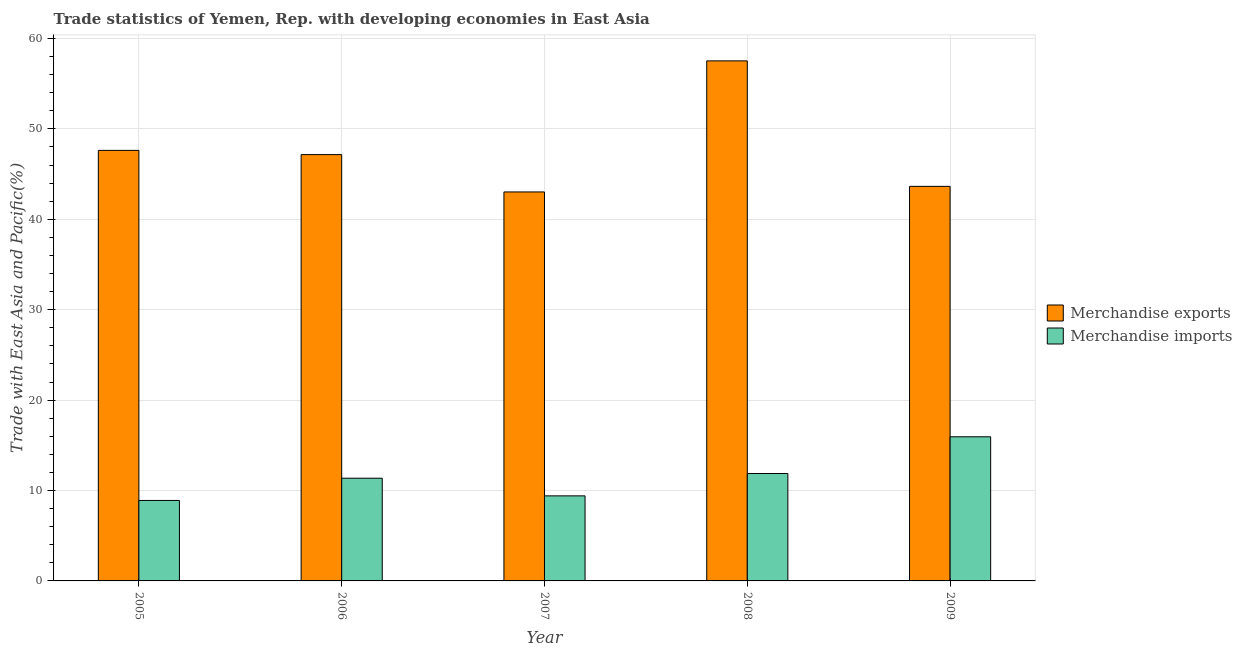How many different coloured bars are there?
Your response must be concise. 2. How many groups of bars are there?
Your answer should be very brief. 5. Are the number of bars on each tick of the X-axis equal?
Offer a terse response. Yes. How many bars are there on the 2nd tick from the left?
Provide a short and direct response. 2. What is the merchandise exports in 2007?
Give a very brief answer. 43.03. Across all years, what is the maximum merchandise exports?
Your response must be concise. 57.53. Across all years, what is the minimum merchandise imports?
Your answer should be very brief. 8.9. What is the total merchandise exports in the graph?
Your response must be concise. 238.98. What is the difference between the merchandise exports in 2006 and that in 2007?
Your answer should be compact. 4.13. What is the difference between the merchandise exports in 2005 and the merchandise imports in 2007?
Provide a succinct answer. 4.6. What is the average merchandise imports per year?
Offer a terse response. 11.5. In the year 2009, what is the difference between the merchandise imports and merchandise exports?
Provide a succinct answer. 0. What is the ratio of the merchandise imports in 2005 to that in 2007?
Provide a succinct answer. 0.95. Is the merchandise imports in 2005 less than that in 2006?
Provide a short and direct response. Yes. What is the difference between the highest and the second highest merchandise imports?
Ensure brevity in your answer.  4.06. What is the difference between the highest and the lowest merchandise exports?
Your answer should be very brief. 14.5. Is the sum of the merchandise imports in 2006 and 2007 greater than the maximum merchandise exports across all years?
Provide a succinct answer. Yes. What does the 1st bar from the left in 2007 represents?
Ensure brevity in your answer.  Merchandise exports. Are all the bars in the graph horizontal?
Your answer should be very brief. No. Are the values on the major ticks of Y-axis written in scientific E-notation?
Ensure brevity in your answer.  No. Does the graph contain any zero values?
Your answer should be very brief. No. How many legend labels are there?
Offer a very short reply. 2. What is the title of the graph?
Offer a terse response. Trade statistics of Yemen, Rep. with developing economies in East Asia. Does "Not attending school" appear as one of the legend labels in the graph?
Offer a very short reply. No. What is the label or title of the X-axis?
Provide a short and direct response. Year. What is the label or title of the Y-axis?
Offer a very short reply. Trade with East Asia and Pacific(%). What is the Trade with East Asia and Pacific(%) in Merchandise exports in 2005?
Make the answer very short. 47.63. What is the Trade with East Asia and Pacific(%) of Merchandise imports in 2005?
Provide a succinct answer. 8.9. What is the Trade with East Asia and Pacific(%) in Merchandise exports in 2006?
Offer a very short reply. 47.16. What is the Trade with East Asia and Pacific(%) in Merchandise imports in 2006?
Give a very brief answer. 11.36. What is the Trade with East Asia and Pacific(%) in Merchandise exports in 2007?
Give a very brief answer. 43.03. What is the Trade with East Asia and Pacific(%) in Merchandise imports in 2007?
Keep it short and to the point. 9.41. What is the Trade with East Asia and Pacific(%) in Merchandise exports in 2008?
Provide a short and direct response. 57.53. What is the Trade with East Asia and Pacific(%) of Merchandise imports in 2008?
Make the answer very short. 11.88. What is the Trade with East Asia and Pacific(%) of Merchandise exports in 2009?
Make the answer very short. 43.65. What is the Trade with East Asia and Pacific(%) of Merchandise imports in 2009?
Your answer should be very brief. 15.94. Across all years, what is the maximum Trade with East Asia and Pacific(%) in Merchandise exports?
Offer a terse response. 57.53. Across all years, what is the maximum Trade with East Asia and Pacific(%) of Merchandise imports?
Your answer should be very brief. 15.94. Across all years, what is the minimum Trade with East Asia and Pacific(%) in Merchandise exports?
Ensure brevity in your answer.  43.03. Across all years, what is the minimum Trade with East Asia and Pacific(%) of Merchandise imports?
Your answer should be very brief. 8.9. What is the total Trade with East Asia and Pacific(%) of Merchandise exports in the graph?
Your response must be concise. 238.98. What is the total Trade with East Asia and Pacific(%) in Merchandise imports in the graph?
Offer a very short reply. 57.5. What is the difference between the Trade with East Asia and Pacific(%) of Merchandise exports in 2005 and that in 2006?
Provide a succinct answer. 0.47. What is the difference between the Trade with East Asia and Pacific(%) of Merchandise imports in 2005 and that in 2006?
Offer a very short reply. -2.46. What is the difference between the Trade with East Asia and Pacific(%) in Merchandise exports in 2005 and that in 2007?
Offer a very short reply. 4.6. What is the difference between the Trade with East Asia and Pacific(%) in Merchandise imports in 2005 and that in 2007?
Give a very brief answer. -0.51. What is the difference between the Trade with East Asia and Pacific(%) of Merchandise exports in 2005 and that in 2008?
Your answer should be compact. -9.9. What is the difference between the Trade with East Asia and Pacific(%) in Merchandise imports in 2005 and that in 2008?
Provide a short and direct response. -2.98. What is the difference between the Trade with East Asia and Pacific(%) in Merchandise exports in 2005 and that in 2009?
Provide a short and direct response. 3.98. What is the difference between the Trade with East Asia and Pacific(%) of Merchandise imports in 2005 and that in 2009?
Offer a terse response. -7.04. What is the difference between the Trade with East Asia and Pacific(%) of Merchandise exports in 2006 and that in 2007?
Provide a short and direct response. 4.13. What is the difference between the Trade with East Asia and Pacific(%) in Merchandise imports in 2006 and that in 2007?
Ensure brevity in your answer.  1.95. What is the difference between the Trade with East Asia and Pacific(%) in Merchandise exports in 2006 and that in 2008?
Your response must be concise. -10.37. What is the difference between the Trade with East Asia and Pacific(%) of Merchandise imports in 2006 and that in 2008?
Give a very brief answer. -0.52. What is the difference between the Trade with East Asia and Pacific(%) of Merchandise exports in 2006 and that in 2009?
Provide a short and direct response. 3.51. What is the difference between the Trade with East Asia and Pacific(%) of Merchandise imports in 2006 and that in 2009?
Your answer should be very brief. -4.58. What is the difference between the Trade with East Asia and Pacific(%) in Merchandise exports in 2007 and that in 2008?
Provide a succinct answer. -14.5. What is the difference between the Trade with East Asia and Pacific(%) in Merchandise imports in 2007 and that in 2008?
Ensure brevity in your answer.  -2.47. What is the difference between the Trade with East Asia and Pacific(%) of Merchandise exports in 2007 and that in 2009?
Your response must be concise. -0.62. What is the difference between the Trade with East Asia and Pacific(%) of Merchandise imports in 2007 and that in 2009?
Give a very brief answer. -6.54. What is the difference between the Trade with East Asia and Pacific(%) of Merchandise exports in 2008 and that in 2009?
Give a very brief answer. 13.88. What is the difference between the Trade with East Asia and Pacific(%) of Merchandise imports in 2008 and that in 2009?
Ensure brevity in your answer.  -4.06. What is the difference between the Trade with East Asia and Pacific(%) of Merchandise exports in 2005 and the Trade with East Asia and Pacific(%) of Merchandise imports in 2006?
Keep it short and to the point. 36.26. What is the difference between the Trade with East Asia and Pacific(%) in Merchandise exports in 2005 and the Trade with East Asia and Pacific(%) in Merchandise imports in 2007?
Offer a terse response. 38.22. What is the difference between the Trade with East Asia and Pacific(%) in Merchandise exports in 2005 and the Trade with East Asia and Pacific(%) in Merchandise imports in 2008?
Your answer should be compact. 35.74. What is the difference between the Trade with East Asia and Pacific(%) in Merchandise exports in 2005 and the Trade with East Asia and Pacific(%) in Merchandise imports in 2009?
Keep it short and to the point. 31.68. What is the difference between the Trade with East Asia and Pacific(%) of Merchandise exports in 2006 and the Trade with East Asia and Pacific(%) of Merchandise imports in 2007?
Make the answer very short. 37.75. What is the difference between the Trade with East Asia and Pacific(%) in Merchandise exports in 2006 and the Trade with East Asia and Pacific(%) in Merchandise imports in 2008?
Keep it short and to the point. 35.28. What is the difference between the Trade with East Asia and Pacific(%) of Merchandise exports in 2006 and the Trade with East Asia and Pacific(%) of Merchandise imports in 2009?
Provide a succinct answer. 31.21. What is the difference between the Trade with East Asia and Pacific(%) in Merchandise exports in 2007 and the Trade with East Asia and Pacific(%) in Merchandise imports in 2008?
Offer a very short reply. 31.15. What is the difference between the Trade with East Asia and Pacific(%) in Merchandise exports in 2007 and the Trade with East Asia and Pacific(%) in Merchandise imports in 2009?
Give a very brief answer. 27.08. What is the difference between the Trade with East Asia and Pacific(%) in Merchandise exports in 2008 and the Trade with East Asia and Pacific(%) in Merchandise imports in 2009?
Provide a succinct answer. 41.58. What is the average Trade with East Asia and Pacific(%) in Merchandise exports per year?
Your response must be concise. 47.8. What is the average Trade with East Asia and Pacific(%) in Merchandise imports per year?
Provide a succinct answer. 11.5. In the year 2005, what is the difference between the Trade with East Asia and Pacific(%) of Merchandise exports and Trade with East Asia and Pacific(%) of Merchandise imports?
Your answer should be very brief. 38.73. In the year 2006, what is the difference between the Trade with East Asia and Pacific(%) of Merchandise exports and Trade with East Asia and Pacific(%) of Merchandise imports?
Provide a succinct answer. 35.8. In the year 2007, what is the difference between the Trade with East Asia and Pacific(%) of Merchandise exports and Trade with East Asia and Pacific(%) of Merchandise imports?
Ensure brevity in your answer.  33.62. In the year 2008, what is the difference between the Trade with East Asia and Pacific(%) in Merchandise exports and Trade with East Asia and Pacific(%) in Merchandise imports?
Ensure brevity in your answer.  45.65. In the year 2009, what is the difference between the Trade with East Asia and Pacific(%) in Merchandise exports and Trade with East Asia and Pacific(%) in Merchandise imports?
Keep it short and to the point. 27.7. What is the ratio of the Trade with East Asia and Pacific(%) in Merchandise exports in 2005 to that in 2006?
Ensure brevity in your answer.  1.01. What is the ratio of the Trade with East Asia and Pacific(%) of Merchandise imports in 2005 to that in 2006?
Offer a very short reply. 0.78. What is the ratio of the Trade with East Asia and Pacific(%) of Merchandise exports in 2005 to that in 2007?
Your answer should be compact. 1.11. What is the ratio of the Trade with East Asia and Pacific(%) in Merchandise imports in 2005 to that in 2007?
Offer a very short reply. 0.95. What is the ratio of the Trade with East Asia and Pacific(%) in Merchandise exports in 2005 to that in 2008?
Your response must be concise. 0.83. What is the ratio of the Trade with East Asia and Pacific(%) in Merchandise imports in 2005 to that in 2008?
Ensure brevity in your answer.  0.75. What is the ratio of the Trade with East Asia and Pacific(%) of Merchandise exports in 2005 to that in 2009?
Your answer should be very brief. 1.09. What is the ratio of the Trade with East Asia and Pacific(%) of Merchandise imports in 2005 to that in 2009?
Your response must be concise. 0.56. What is the ratio of the Trade with East Asia and Pacific(%) in Merchandise exports in 2006 to that in 2007?
Your answer should be compact. 1.1. What is the ratio of the Trade with East Asia and Pacific(%) in Merchandise imports in 2006 to that in 2007?
Your answer should be compact. 1.21. What is the ratio of the Trade with East Asia and Pacific(%) of Merchandise exports in 2006 to that in 2008?
Your answer should be compact. 0.82. What is the ratio of the Trade with East Asia and Pacific(%) of Merchandise imports in 2006 to that in 2008?
Your answer should be very brief. 0.96. What is the ratio of the Trade with East Asia and Pacific(%) of Merchandise exports in 2006 to that in 2009?
Offer a very short reply. 1.08. What is the ratio of the Trade with East Asia and Pacific(%) of Merchandise imports in 2006 to that in 2009?
Give a very brief answer. 0.71. What is the ratio of the Trade with East Asia and Pacific(%) in Merchandise exports in 2007 to that in 2008?
Your answer should be very brief. 0.75. What is the ratio of the Trade with East Asia and Pacific(%) of Merchandise imports in 2007 to that in 2008?
Give a very brief answer. 0.79. What is the ratio of the Trade with East Asia and Pacific(%) in Merchandise exports in 2007 to that in 2009?
Provide a short and direct response. 0.99. What is the ratio of the Trade with East Asia and Pacific(%) of Merchandise imports in 2007 to that in 2009?
Make the answer very short. 0.59. What is the ratio of the Trade with East Asia and Pacific(%) in Merchandise exports in 2008 to that in 2009?
Ensure brevity in your answer.  1.32. What is the ratio of the Trade with East Asia and Pacific(%) of Merchandise imports in 2008 to that in 2009?
Make the answer very short. 0.75. What is the difference between the highest and the second highest Trade with East Asia and Pacific(%) in Merchandise exports?
Ensure brevity in your answer.  9.9. What is the difference between the highest and the second highest Trade with East Asia and Pacific(%) in Merchandise imports?
Make the answer very short. 4.06. What is the difference between the highest and the lowest Trade with East Asia and Pacific(%) of Merchandise exports?
Keep it short and to the point. 14.5. What is the difference between the highest and the lowest Trade with East Asia and Pacific(%) in Merchandise imports?
Give a very brief answer. 7.04. 